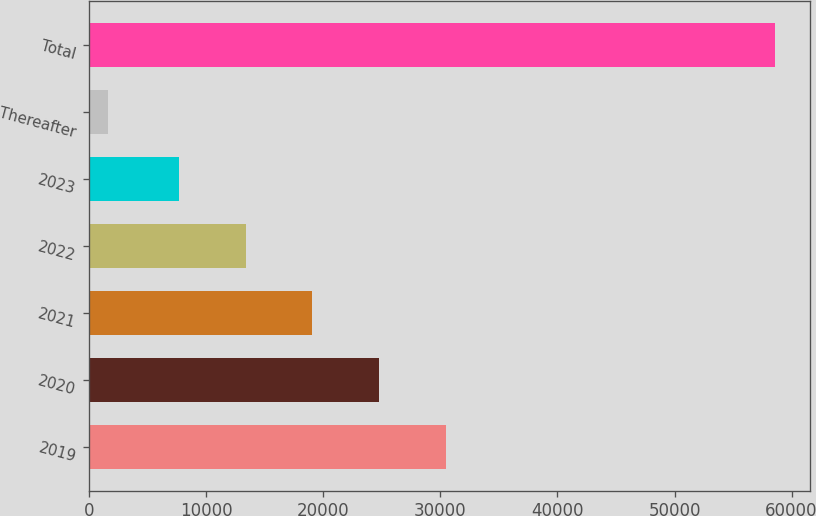Convert chart to OTSL. <chart><loc_0><loc_0><loc_500><loc_500><bar_chart><fcel>2019<fcel>2020<fcel>2021<fcel>2022<fcel>2023<fcel>Thereafter<fcel>Total<nl><fcel>30475.2<fcel>24778.9<fcel>19082.6<fcel>13386.3<fcel>7690<fcel>1647<fcel>58610<nl></chart> 